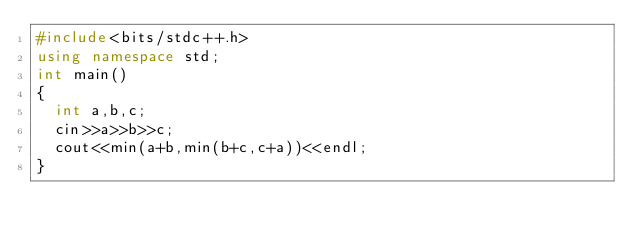Convert code to text. <code><loc_0><loc_0><loc_500><loc_500><_C++_>#include<bits/stdc++.h>
using namespace std;
int main()
{
  int a,b,c;
  cin>>a>>b>>c;
  cout<<min(a+b,min(b+c,c+a))<<endl;
}</code> 